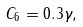Convert formula to latex. <formula><loc_0><loc_0><loc_500><loc_500>C _ { 6 } = 0 . 3 \gamma ,</formula> 